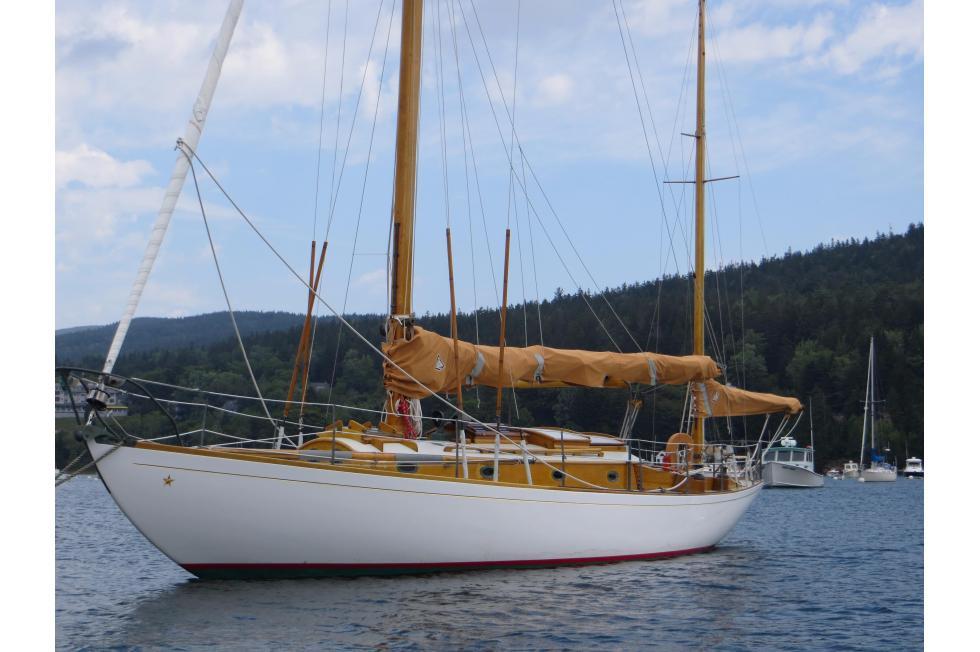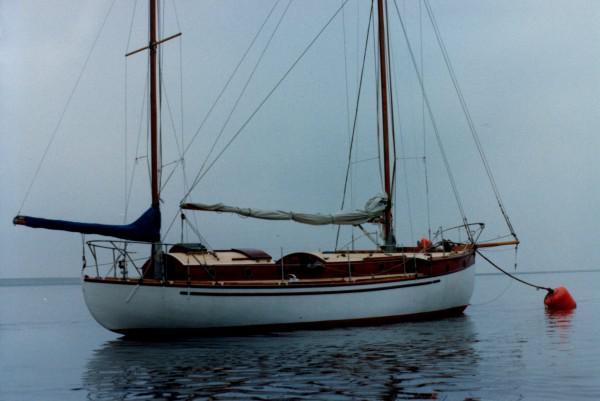The first image is the image on the left, the second image is the image on the right. Evaluate the accuracy of this statement regarding the images: "On the right side of an image, a floating buoy extends from a boat into the water by a rope.". Is it true? Answer yes or no. Yes. The first image is the image on the left, the second image is the image on the right. Examine the images to the left and right. Is the description "The sailboat in the image on the right has a black body." accurate? Answer yes or no. No. 